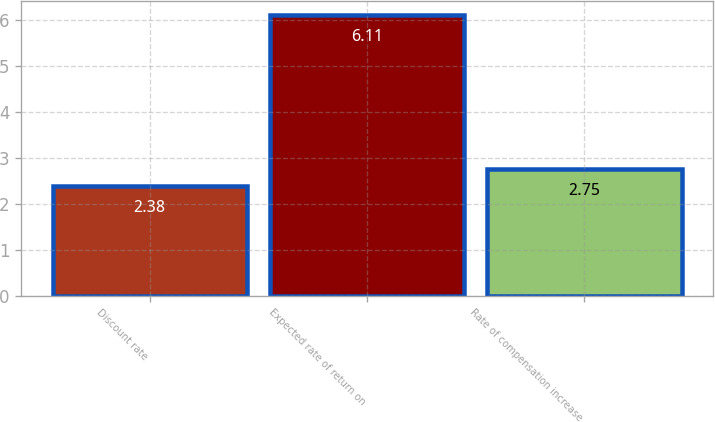Convert chart to OTSL. <chart><loc_0><loc_0><loc_500><loc_500><bar_chart><fcel>Discount rate<fcel>Expected rate of return on<fcel>Rate of compensation increase<nl><fcel>2.38<fcel>6.11<fcel>2.75<nl></chart> 